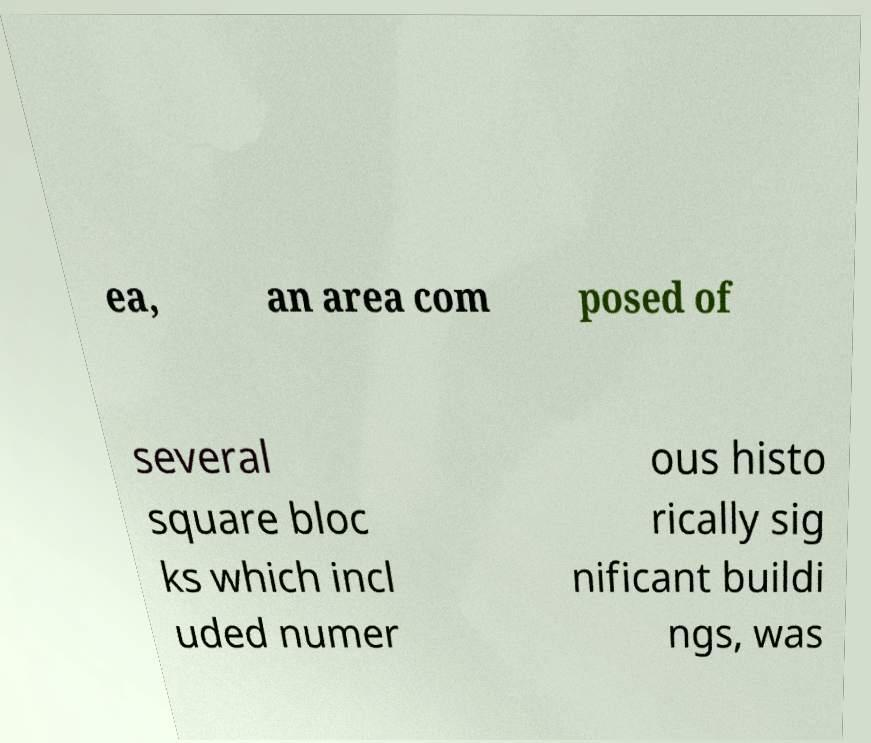There's text embedded in this image that I need extracted. Can you transcribe it verbatim? ea, an area com posed of several square bloc ks which incl uded numer ous histo rically sig nificant buildi ngs, was 